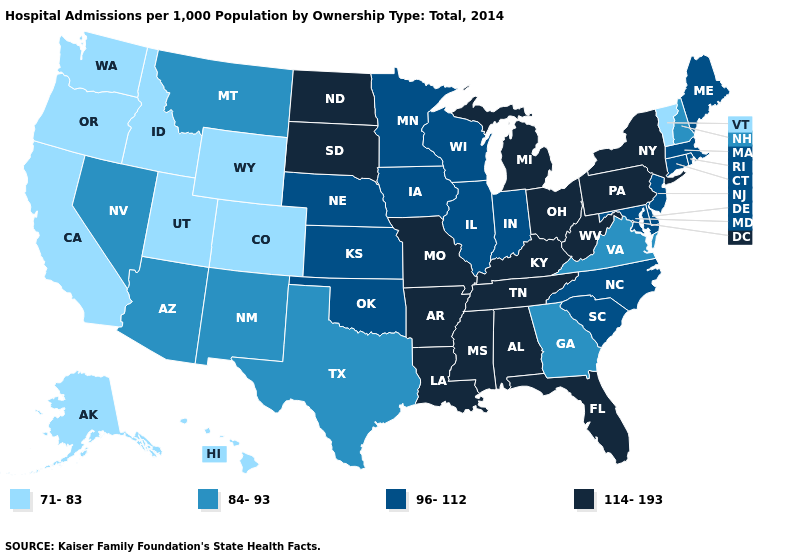What is the highest value in states that border Alabama?
Give a very brief answer. 114-193. Among the states that border North Dakota , which have the lowest value?
Keep it brief. Montana. Name the states that have a value in the range 71-83?
Give a very brief answer. Alaska, California, Colorado, Hawaii, Idaho, Oregon, Utah, Vermont, Washington, Wyoming. Among the states that border California , does Oregon have the highest value?
Give a very brief answer. No. Name the states that have a value in the range 84-93?
Concise answer only. Arizona, Georgia, Montana, Nevada, New Hampshire, New Mexico, Texas, Virginia. What is the value of Florida?
Give a very brief answer. 114-193. What is the lowest value in the USA?
Be succinct. 71-83. Which states have the highest value in the USA?
Quick response, please. Alabama, Arkansas, Florida, Kentucky, Louisiana, Michigan, Mississippi, Missouri, New York, North Dakota, Ohio, Pennsylvania, South Dakota, Tennessee, West Virginia. What is the value of Iowa?
Short answer required. 96-112. Does Utah have the highest value in the USA?
Short answer required. No. Which states hav the highest value in the West?
Short answer required. Arizona, Montana, Nevada, New Mexico. Does Minnesota have a higher value than North Dakota?
Write a very short answer. No. What is the value of Nevada?
Concise answer only. 84-93. Does California have the lowest value in the USA?
Answer briefly. Yes. Does New York have the highest value in the USA?
Give a very brief answer. Yes. 